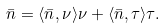Convert formula to latex. <formula><loc_0><loc_0><loc_500><loc_500>\bar { n } = \langle \bar { n } , \nu \rangle \nu + \langle \bar { n } , \tau \rangle \tau .</formula> 